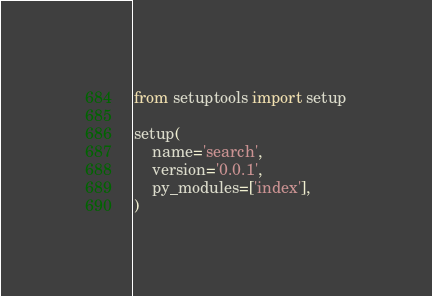<code> <loc_0><loc_0><loc_500><loc_500><_Python_>from setuptools import setup

setup(
    name='search',
    version='0.0.1',
    py_modules=['index'],
)
</code> 